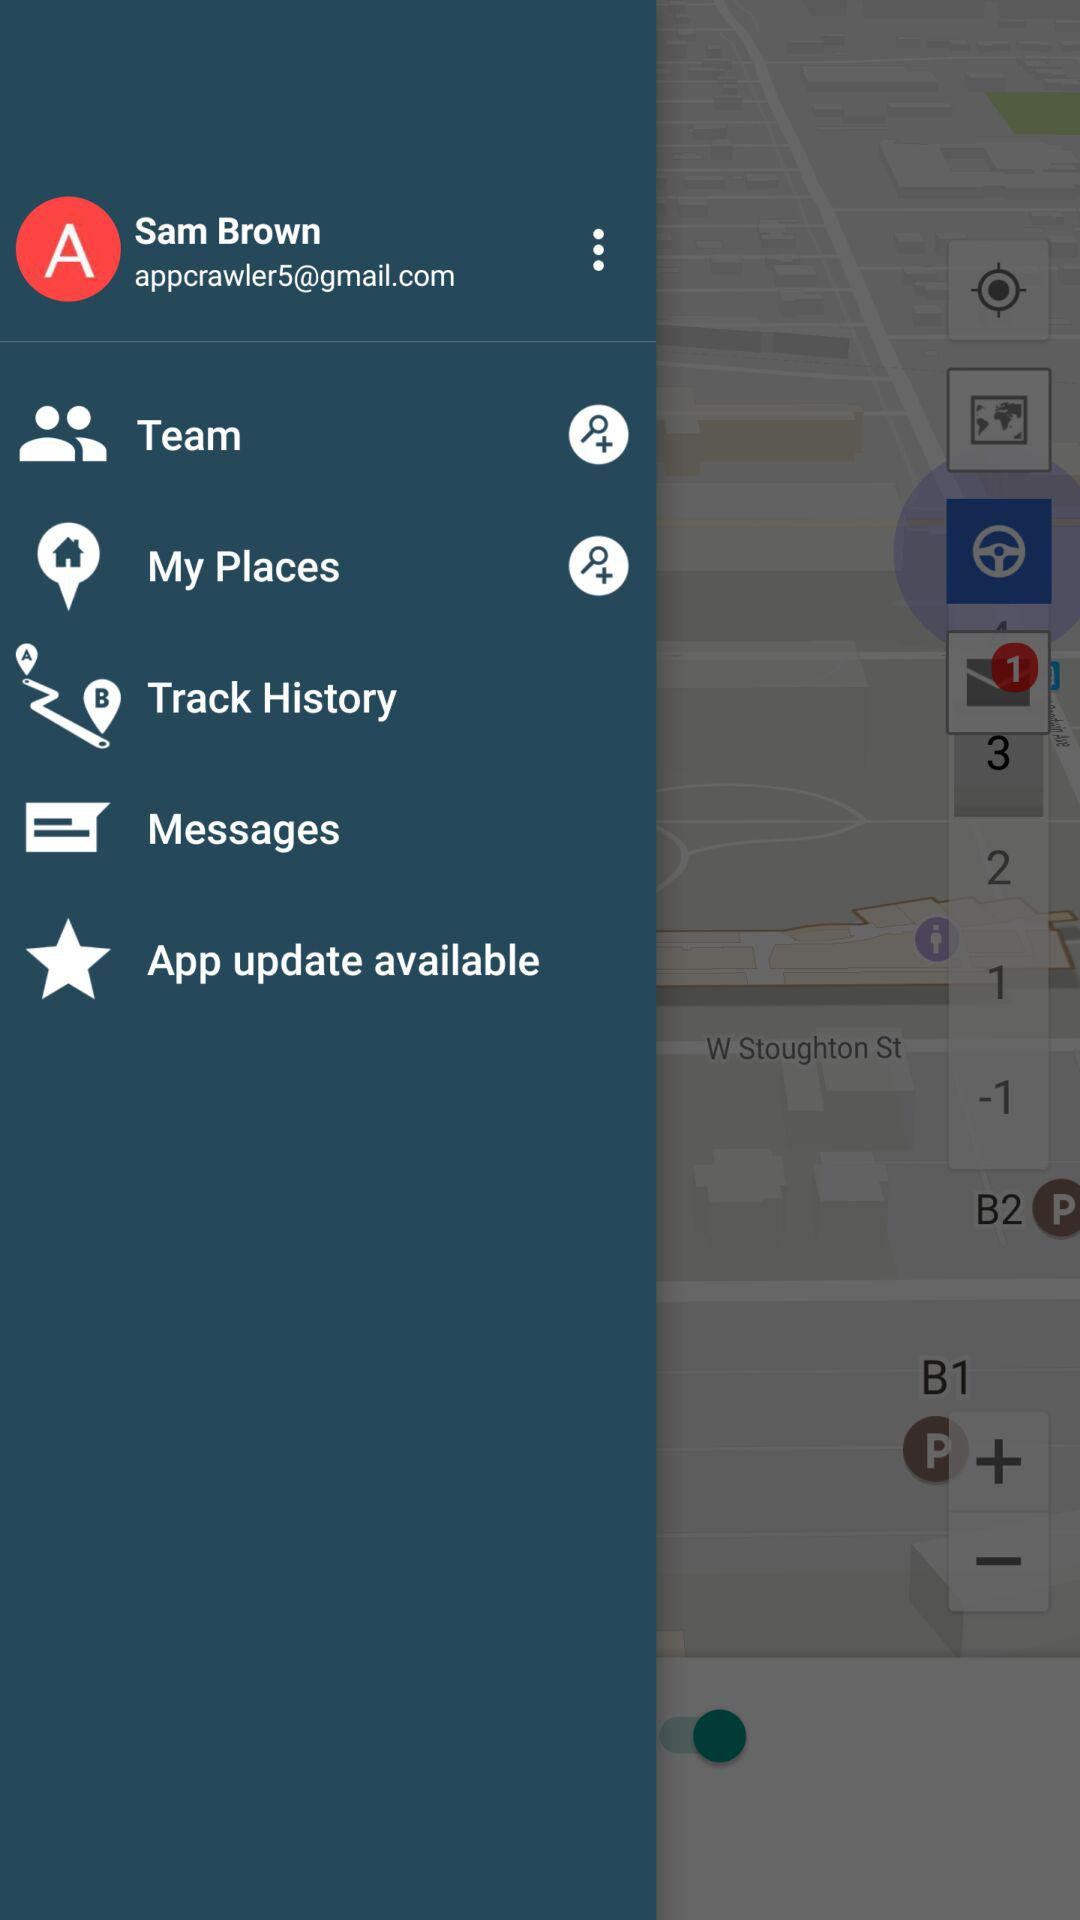What is the email address? The email address is appcrawler5@gmail.com. 